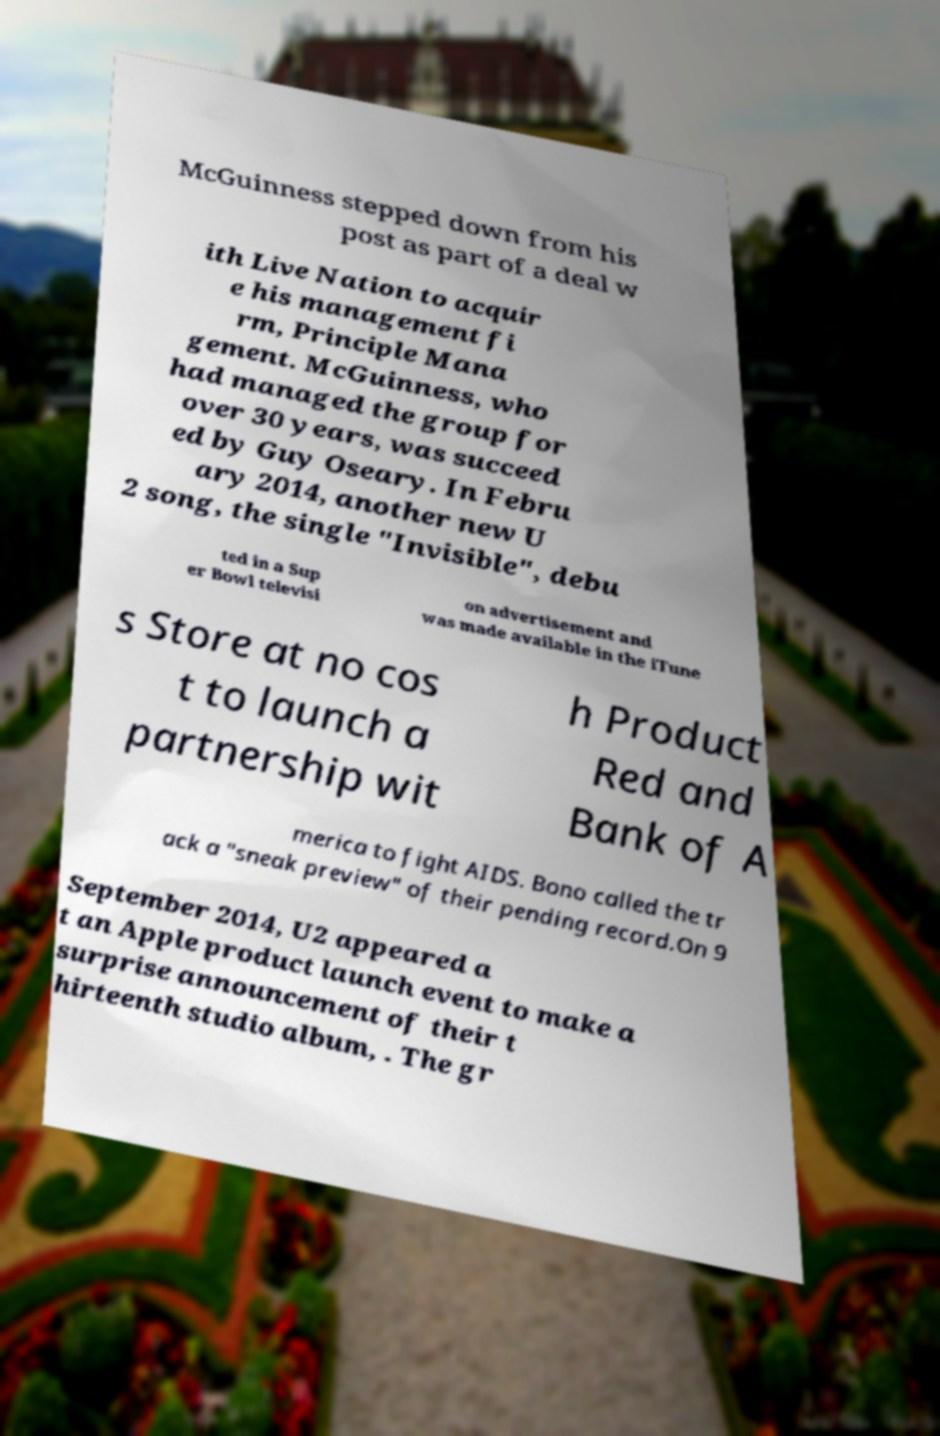Please read and relay the text visible in this image. What does it say? McGuinness stepped down from his post as part of a deal w ith Live Nation to acquir e his management fi rm, Principle Mana gement. McGuinness, who had managed the group for over 30 years, was succeed ed by Guy Oseary. In Febru ary 2014, another new U 2 song, the single "Invisible", debu ted in a Sup er Bowl televisi on advertisement and was made available in the iTune s Store at no cos t to launch a partnership wit h Product Red and Bank of A merica to fight AIDS. Bono called the tr ack a "sneak preview" of their pending record.On 9 September 2014, U2 appeared a t an Apple product launch event to make a surprise announcement of their t hirteenth studio album, . The gr 